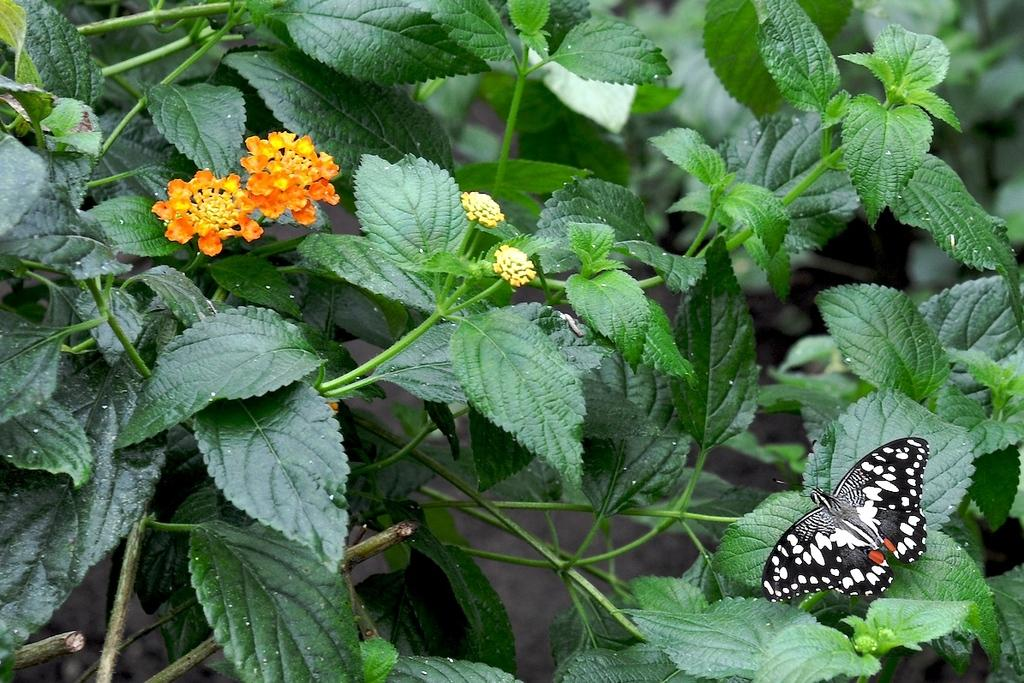What is the main subject of the image? The main subject of the image is a butterfly. Where is the butterfly located in the image? The butterfly is on flower plants. What type of pie is being served on the flower plants in the image? There is no pie present in the image; it features a butterfly on flower plants. What type of soap is visible in the image? There is no soap present in the image. 